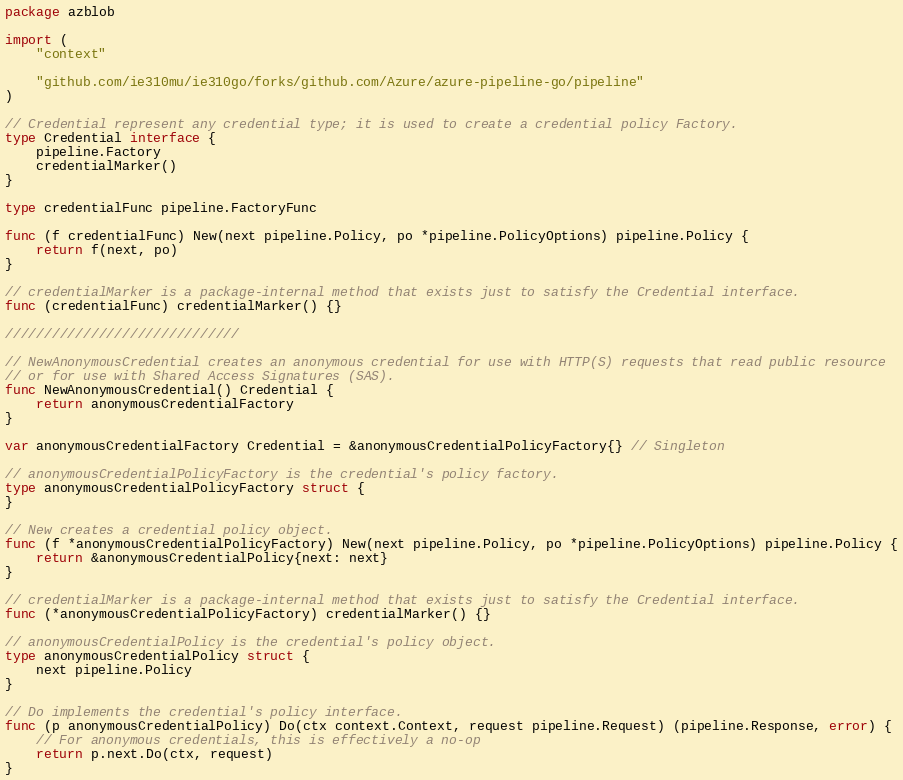<code> <loc_0><loc_0><loc_500><loc_500><_Go_>package azblob

import (
	"context"

	"github.com/ie310mu/ie310go/forks/github.com/Azure/azure-pipeline-go/pipeline"
)

// Credential represent any credential type; it is used to create a credential policy Factory.
type Credential interface {
	pipeline.Factory
	credentialMarker()
}

type credentialFunc pipeline.FactoryFunc

func (f credentialFunc) New(next pipeline.Policy, po *pipeline.PolicyOptions) pipeline.Policy {
	return f(next, po)
}

// credentialMarker is a package-internal method that exists just to satisfy the Credential interface.
func (credentialFunc) credentialMarker() {}

//////////////////////////////

// NewAnonymousCredential creates an anonymous credential for use with HTTP(S) requests that read public resource
// or for use with Shared Access Signatures (SAS).
func NewAnonymousCredential() Credential {
	return anonymousCredentialFactory
}

var anonymousCredentialFactory Credential = &anonymousCredentialPolicyFactory{} // Singleton

// anonymousCredentialPolicyFactory is the credential's policy factory.
type anonymousCredentialPolicyFactory struct {
}

// New creates a credential policy object.
func (f *anonymousCredentialPolicyFactory) New(next pipeline.Policy, po *pipeline.PolicyOptions) pipeline.Policy {
	return &anonymousCredentialPolicy{next: next}
}

// credentialMarker is a package-internal method that exists just to satisfy the Credential interface.
func (*anonymousCredentialPolicyFactory) credentialMarker() {}

// anonymousCredentialPolicy is the credential's policy object.
type anonymousCredentialPolicy struct {
	next pipeline.Policy
}

// Do implements the credential's policy interface.
func (p anonymousCredentialPolicy) Do(ctx context.Context, request pipeline.Request) (pipeline.Response, error) {
	// For anonymous credentials, this is effectively a no-op
	return p.next.Do(ctx, request)
}
</code> 